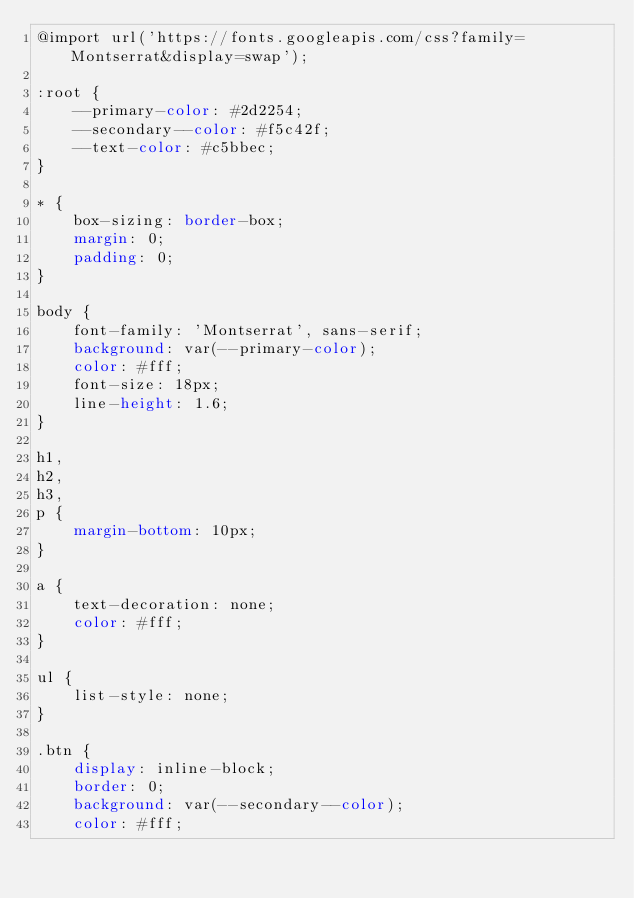Convert code to text. <code><loc_0><loc_0><loc_500><loc_500><_CSS_>@import url('https://fonts.googleapis.com/css?family=Montserrat&display=swap');

:root {
	--primary-color: #2d2254;
	--secondary--color: #f5c42f;
	--text-color: #c5bbec;
}

* {
	box-sizing: border-box;
	margin: 0;
	padding: 0;
}

body {
	font-family: 'Montserrat', sans-serif;
	background: var(--primary-color);
	color: #fff;
	font-size: 18px;
	line-height: 1.6;
}

h1,
h2,
h3,
p {
	margin-bottom: 10px;
}

a {
	text-decoration: none;
	color: #fff;
}

ul {
	list-style: none;
}

.btn {
	display: inline-block;
	border: 0;
	background: var(--secondary--color);
	color: #fff;</code> 